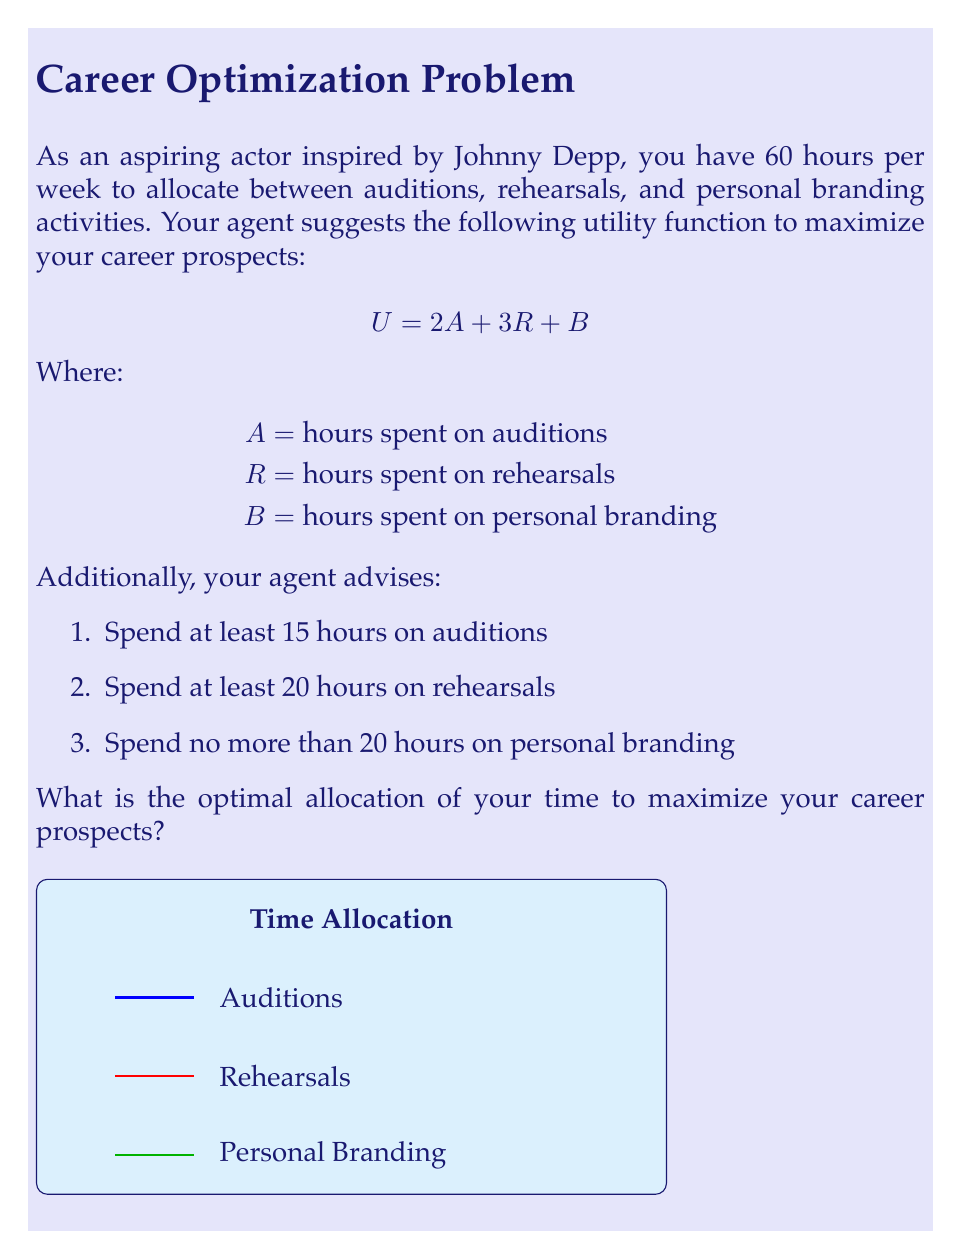Can you solve this math problem? Let's approach this problem using linear programming:

1) Define variables:
   $A$ = hours for auditions
   $R$ = hours for rehearsals
   $B$ = hours for personal branding

2) Objective function (to maximize):
   $U = 2A + 3R + B$

3) Constraints:
   $A + R + B \leq 60$ (total time constraint)
   $A \geq 15$ (minimum audition time)
   $R \geq 20$ (minimum rehearsal time)
   $B \leq 20$ (maximum personal branding time)
   $A, R, B \geq 0$ (non-negativity constraints)

4) To solve this, we can use the corner point method. The optimal solution will be at one of the corners of the feasible region.

5) The binding constraints are:
   $A + R + B = 60$ (we want to use all available time)
   $R = 20$ (minimum rehearsal time, as it has the highest coefficient)
   $B = 20$ (maximum personal branding time, as it has the lowest coefficient)

6) Solving these equations:
   $A + 20 + 20 = 60$
   $A = 20$

7) Therefore, the optimal allocation is:
   $A = 20$ hours for auditions
   $R = 20$ hours for rehearsals
   $B = 20$ hours for personal branding

8) We can verify that this satisfies all constraints and maximizes the utility:
   $U = 2(20) + 3(20) + 20 = 120$

This allocation balances the time spent on each activity while maximizing the utility function provided by the agent.
Answer: Auditions: 20 hours, Rehearsals: 20 hours, Personal Branding: 20 hours 